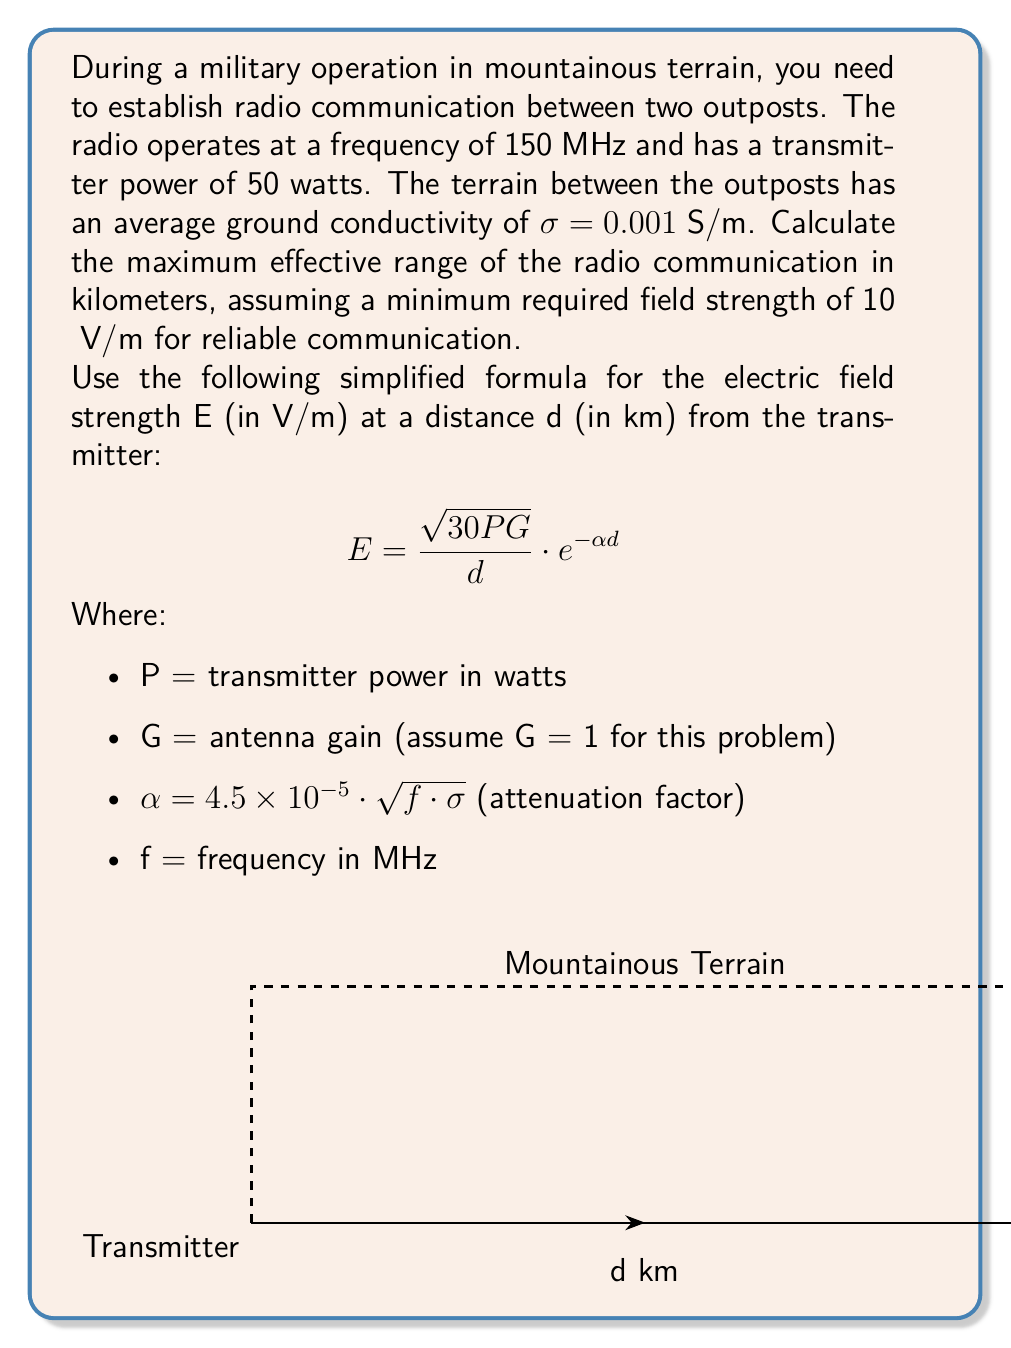What is the answer to this math problem? Let's approach this problem step-by-step:

1) First, we need to calculate the attenuation factor $\alpha$:
   $$\alpha = 4.5 \times 10^{-5} \cdot \sqrt{f \cdot \sigma}$$
   $$\alpha = 4.5 \times 10^{-5} \cdot \sqrt{150 \cdot 0.001}$$
   $$\alpha = 4.5 \times 10^{-5} \cdot \sqrt{0.15} \approx 1.743 \times 10^{-5}$$

2) Now, we can set up the equation using the given formula:
   $$10 \times 10^{-6} = \frac{\sqrt{30 \cdot 50 \cdot 1}}{d} \cdot e^{-1.743 \times 10^{-5} \cdot d}$$

3) Simplify the left side of the equation:
   $$\frac{\sqrt{1500}}{d} \cdot e^{-1.743 \times 10^{-5} \cdot d} = 10^{-5}$$

4) Multiply both sides by d:
   $$\sqrt{1500} \cdot e^{-1.743 \times 10^{-5} \cdot d} = 10^{-5} \cdot d$$

5) Take the natural log of both sides:
   $$\ln(\sqrt{1500}) - 1.743 \times 10^{-5} \cdot d = \ln(10^{-5} \cdot d)$$

6) Simplify:
   $$3.91 - 1.743 \times 10^{-5} \cdot d = \ln(d) - 11.51$$

7) Rearrange:
   $$15.42 = \ln(d) + 1.743 \times 10^{-5} \cdot d$$

This equation cannot be solved analytically. We need to use a numerical method like Newton-Raphson or use a graphing calculator to find the solution. 

Using a numerical solver, we find that d ≈ 103.7 km.
Answer: 103.7 km 